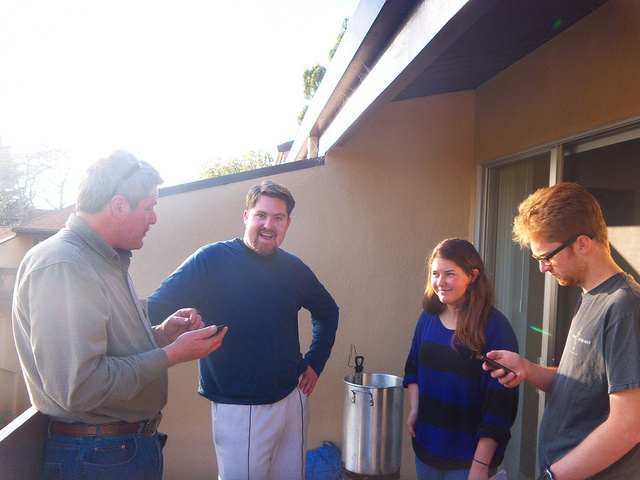Describe the objects in this image and their specific colors. I can see people in white, darkgray, gray, navy, and lightgray tones, people in white, navy, gray, darkgray, and darkblue tones, people in white, brown, gray, maroon, and black tones, people in white, black, navy, maroon, and brown tones, and backpack in white, blue, and darkblue tones in this image. 